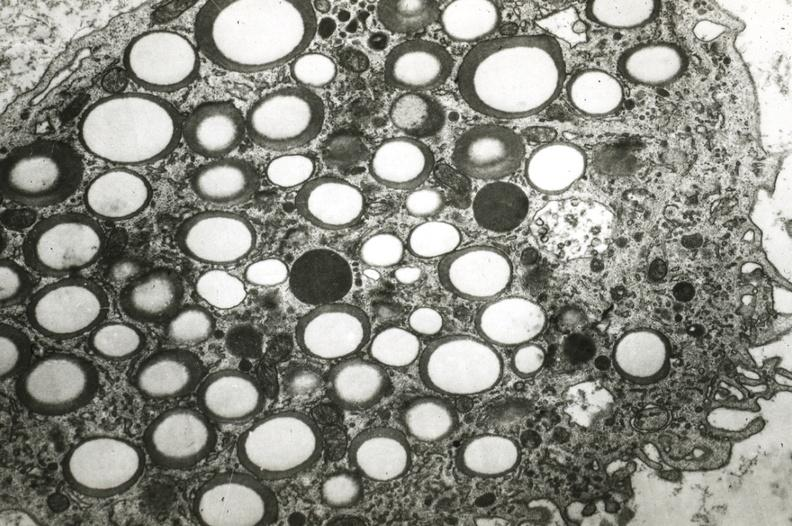does this image show foam cell?
Answer the question using a single word or phrase. Yes 